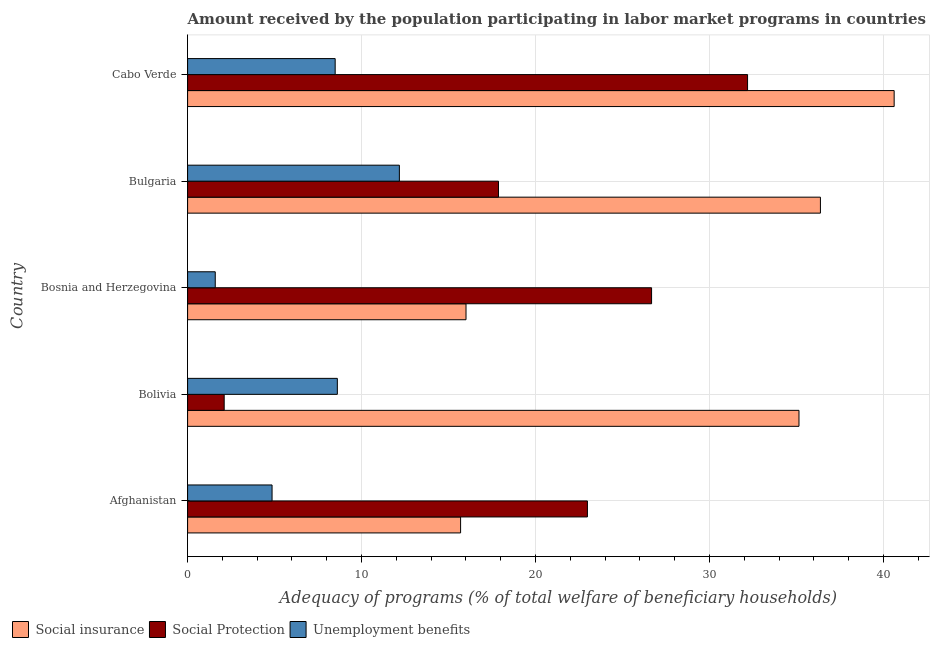Are the number of bars on each tick of the Y-axis equal?
Make the answer very short. Yes. How many bars are there on the 5th tick from the top?
Your answer should be very brief. 3. In how many cases, is the number of bars for a given country not equal to the number of legend labels?
Your answer should be very brief. 0. What is the amount received by the population participating in social protection programs in Bolivia?
Your answer should be compact. 2.1. Across all countries, what is the maximum amount received by the population participating in social protection programs?
Provide a short and direct response. 32.19. Across all countries, what is the minimum amount received by the population participating in social protection programs?
Offer a very short reply. 2.1. In which country was the amount received by the population participating in unemployment benefits programs maximum?
Give a very brief answer. Bulgaria. In which country was the amount received by the population participating in social insurance programs minimum?
Provide a short and direct response. Afghanistan. What is the total amount received by the population participating in social protection programs in the graph?
Your answer should be very brief. 101.83. What is the difference between the amount received by the population participating in social protection programs in Afghanistan and that in Bosnia and Herzegovina?
Offer a terse response. -3.69. What is the difference between the amount received by the population participating in social protection programs in Bulgaria and the amount received by the population participating in social insurance programs in Afghanistan?
Provide a short and direct response. 2.18. What is the average amount received by the population participating in unemployment benefits programs per country?
Your answer should be compact. 7.14. What is the difference between the amount received by the population participating in social insurance programs and amount received by the population participating in social protection programs in Bosnia and Herzegovina?
Your answer should be very brief. -10.67. In how many countries, is the amount received by the population participating in social protection programs greater than 6 %?
Provide a succinct answer. 4. What is the ratio of the amount received by the population participating in unemployment benefits programs in Bulgaria to that in Cabo Verde?
Your response must be concise. 1.44. Is the amount received by the population participating in social insurance programs in Bulgaria less than that in Cabo Verde?
Provide a succinct answer. Yes. Is the difference between the amount received by the population participating in unemployment benefits programs in Bosnia and Herzegovina and Cabo Verde greater than the difference between the amount received by the population participating in social insurance programs in Bosnia and Herzegovina and Cabo Verde?
Your answer should be very brief. Yes. What is the difference between the highest and the second highest amount received by the population participating in social insurance programs?
Provide a short and direct response. 4.24. What is the difference between the highest and the lowest amount received by the population participating in social insurance programs?
Your answer should be compact. 24.93. In how many countries, is the amount received by the population participating in unemployment benefits programs greater than the average amount received by the population participating in unemployment benefits programs taken over all countries?
Your answer should be very brief. 3. Is the sum of the amount received by the population participating in social insurance programs in Bosnia and Herzegovina and Cabo Verde greater than the maximum amount received by the population participating in unemployment benefits programs across all countries?
Provide a succinct answer. Yes. What does the 3rd bar from the top in Bosnia and Herzegovina represents?
Make the answer very short. Social insurance. What does the 3rd bar from the bottom in Bulgaria represents?
Offer a very short reply. Unemployment benefits. What is the difference between two consecutive major ticks on the X-axis?
Give a very brief answer. 10. Does the graph contain grids?
Your answer should be compact. Yes. How many legend labels are there?
Ensure brevity in your answer.  3. What is the title of the graph?
Ensure brevity in your answer.  Amount received by the population participating in labor market programs in countries. Does "Agriculture" appear as one of the legend labels in the graph?
Give a very brief answer. No. What is the label or title of the X-axis?
Your answer should be compact. Adequacy of programs (% of total welfare of beneficiary households). What is the Adequacy of programs (% of total welfare of beneficiary households) in Social insurance in Afghanistan?
Ensure brevity in your answer.  15.7. What is the Adequacy of programs (% of total welfare of beneficiary households) of Social Protection in Afghanistan?
Keep it short and to the point. 22.99. What is the Adequacy of programs (% of total welfare of beneficiary households) in Unemployment benefits in Afghanistan?
Your answer should be compact. 4.86. What is the Adequacy of programs (% of total welfare of beneficiary households) of Social insurance in Bolivia?
Give a very brief answer. 35.15. What is the Adequacy of programs (% of total welfare of beneficiary households) in Social Protection in Bolivia?
Offer a very short reply. 2.1. What is the Adequacy of programs (% of total welfare of beneficiary households) of Unemployment benefits in Bolivia?
Your answer should be very brief. 8.61. What is the Adequacy of programs (% of total welfare of beneficiary households) of Social insurance in Bosnia and Herzegovina?
Keep it short and to the point. 16.01. What is the Adequacy of programs (% of total welfare of beneficiary households) in Social Protection in Bosnia and Herzegovina?
Ensure brevity in your answer.  26.67. What is the Adequacy of programs (% of total welfare of beneficiary households) in Unemployment benefits in Bosnia and Herzegovina?
Provide a succinct answer. 1.59. What is the Adequacy of programs (% of total welfare of beneficiary households) in Social insurance in Bulgaria?
Your response must be concise. 36.38. What is the Adequacy of programs (% of total welfare of beneficiary households) in Social Protection in Bulgaria?
Your answer should be very brief. 17.87. What is the Adequacy of programs (% of total welfare of beneficiary households) of Unemployment benefits in Bulgaria?
Provide a succinct answer. 12.17. What is the Adequacy of programs (% of total welfare of beneficiary households) in Social insurance in Cabo Verde?
Your response must be concise. 40.62. What is the Adequacy of programs (% of total welfare of beneficiary households) in Social Protection in Cabo Verde?
Offer a terse response. 32.19. What is the Adequacy of programs (% of total welfare of beneficiary households) of Unemployment benefits in Cabo Verde?
Your response must be concise. 8.48. Across all countries, what is the maximum Adequacy of programs (% of total welfare of beneficiary households) in Social insurance?
Provide a short and direct response. 40.62. Across all countries, what is the maximum Adequacy of programs (% of total welfare of beneficiary households) of Social Protection?
Give a very brief answer. 32.19. Across all countries, what is the maximum Adequacy of programs (% of total welfare of beneficiary households) in Unemployment benefits?
Offer a terse response. 12.17. Across all countries, what is the minimum Adequacy of programs (% of total welfare of beneficiary households) in Social insurance?
Offer a very short reply. 15.7. Across all countries, what is the minimum Adequacy of programs (% of total welfare of beneficiary households) in Social Protection?
Ensure brevity in your answer.  2.1. Across all countries, what is the minimum Adequacy of programs (% of total welfare of beneficiary households) of Unemployment benefits?
Your answer should be very brief. 1.59. What is the total Adequacy of programs (% of total welfare of beneficiary households) in Social insurance in the graph?
Your answer should be very brief. 143.85. What is the total Adequacy of programs (% of total welfare of beneficiary households) in Social Protection in the graph?
Offer a terse response. 101.83. What is the total Adequacy of programs (% of total welfare of beneficiary households) in Unemployment benefits in the graph?
Offer a very short reply. 35.71. What is the difference between the Adequacy of programs (% of total welfare of beneficiary households) of Social insurance in Afghanistan and that in Bolivia?
Give a very brief answer. -19.45. What is the difference between the Adequacy of programs (% of total welfare of beneficiary households) of Social Protection in Afghanistan and that in Bolivia?
Make the answer very short. 20.88. What is the difference between the Adequacy of programs (% of total welfare of beneficiary households) in Unemployment benefits in Afghanistan and that in Bolivia?
Offer a terse response. -3.75. What is the difference between the Adequacy of programs (% of total welfare of beneficiary households) of Social insurance in Afghanistan and that in Bosnia and Herzegovina?
Keep it short and to the point. -0.31. What is the difference between the Adequacy of programs (% of total welfare of beneficiary households) in Social Protection in Afghanistan and that in Bosnia and Herzegovina?
Ensure brevity in your answer.  -3.69. What is the difference between the Adequacy of programs (% of total welfare of beneficiary households) of Unemployment benefits in Afghanistan and that in Bosnia and Herzegovina?
Ensure brevity in your answer.  3.27. What is the difference between the Adequacy of programs (% of total welfare of beneficiary households) in Social insurance in Afghanistan and that in Bulgaria?
Provide a short and direct response. -20.69. What is the difference between the Adequacy of programs (% of total welfare of beneficiary households) in Social Protection in Afghanistan and that in Bulgaria?
Ensure brevity in your answer.  5.11. What is the difference between the Adequacy of programs (% of total welfare of beneficiary households) in Unemployment benefits in Afghanistan and that in Bulgaria?
Keep it short and to the point. -7.32. What is the difference between the Adequacy of programs (% of total welfare of beneficiary households) of Social insurance in Afghanistan and that in Cabo Verde?
Offer a terse response. -24.93. What is the difference between the Adequacy of programs (% of total welfare of beneficiary households) in Social Protection in Afghanistan and that in Cabo Verde?
Ensure brevity in your answer.  -9.21. What is the difference between the Adequacy of programs (% of total welfare of beneficiary households) in Unemployment benefits in Afghanistan and that in Cabo Verde?
Make the answer very short. -3.63. What is the difference between the Adequacy of programs (% of total welfare of beneficiary households) of Social insurance in Bolivia and that in Bosnia and Herzegovina?
Your answer should be compact. 19.14. What is the difference between the Adequacy of programs (% of total welfare of beneficiary households) in Social Protection in Bolivia and that in Bosnia and Herzegovina?
Keep it short and to the point. -24.57. What is the difference between the Adequacy of programs (% of total welfare of beneficiary households) in Unemployment benefits in Bolivia and that in Bosnia and Herzegovina?
Give a very brief answer. 7.02. What is the difference between the Adequacy of programs (% of total welfare of beneficiary households) of Social insurance in Bolivia and that in Bulgaria?
Ensure brevity in your answer.  -1.23. What is the difference between the Adequacy of programs (% of total welfare of beneficiary households) of Social Protection in Bolivia and that in Bulgaria?
Make the answer very short. -15.77. What is the difference between the Adequacy of programs (% of total welfare of beneficiary households) of Unemployment benefits in Bolivia and that in Bulgaria?
Your response must be concise. -3.57. What is the difference between the Adequacy of programs (% of total welfare of beneficiary households) of Social insurance in Bolivia and that in Cabo Verde?
Make the answer very short. -5.47. What is the difference between the Adequacy of programs (% of total welfare of beneficiary households) of Social Protection in Bolivia and that in Cabo Verde?
Provide a short and direct response. -30.09. What is the difference between the Adequacy of programs (% of total welfare of beneficiary households) of Unemployment benefits in Bolivia and that in Cabo Verde?
Your answer should be very brief. 0.12. What is the difference between the Adequacy of programs (% of total welfare of beneficiary households) of Social insurance in Bosnia and Herzegovina and that in Bulgaria?
Provide a succinct answer. -20.38. What is the difference between the Adequacy of programs (% of total welfare of beneficiary households) of Social Protection in Bosnia and Herzegovina and that in Bulgaria?
Ensure brevity in your answer.  8.8. What is the difference between the Adequacy of programs (% of total welfare of beneficiary households) of Unemployment benefits in Bosnia and Herzegovina and that in Bulgaria?
Offer a terse response. -10.59. What is the difference between the Adequacy of programs (% of total welfare of beneficiary households) in Social insurance in Bosnia and Herzegovina and that in Cabo Verde?
Give a very brief answer. -24.61. What is the difference between the Adequacy of programs (% of total welfare of beneficiary households) in Social Protection in Bosnia and Herzegovina and that in Cabo Verde?
Your answer should be compact. -5.52. What is the difference between the Adequacy of programs (% of total welfare of beneficiary households) in Unemployment benefits in Bosnia and Herzegovina and that in Cabo Verde?
Your answer should be compact. -6.89. What is the difference between the Adequacy of programs (% of total welfare of beneficiary households) in Social insurance in Bulgaria and that in Cabo Verde?
Ensure brevity in your answer.  -4.24. What is the difference between the Adequacy of programs (% of total welfare of beneficiary households) in Social Protection in Bulgaria and that in Cabo Verde?
Make the answer very short. -14.32. What is the difference between the Adequacy of programs (% of total welfare of beneficiary households) of Unemployment benefits in Bulgaria and that in Cabo Verde?
Offer a terse response. 3.69. What is the difference between the Adequacy of programs (% of total welfare of beneficiary households) of Social insurance in Afghanistan and the Adequacy of programs (% of total welfare of beneficiary households) of Social Protection in Bolivia?
Your answer should be very brief. 13.59. What is the difference between the Adequacy of programs (% of total welfare of beneficiary households) of Social insurance in Afghanistan and the Adequacy of programs (% of total welfare of beneficiary households) of Unemployment benefits in Bolivia?
Offer a terse response. 7.09. What is the difference between the Adequacy of programs (% of total welfare of beneficiary households) of Social Protection in Afghanistan and the Adequacy of programs (% of total welfare of beneficiary households) of Unemployment benefits in Bolivia?
Offer a terse response. 14.38. What is the difference between the Adequacy of programs (% of total welfare of beneficiary households) in Social insurance in Afghanistan and the Adequacy of programs (% of total welfare of beneficiary households) in Social Protection in Bosnia and Herzegovina?
Your answer should be very brief. -10.98. What is the difference between the Adequacy of programs (% of total welfare of beneficiary households) of Social insurance in Afghanistan and the Adequacy of programs (% of total welfare of beneficiary households) of Unemployment benefits in Bosnia and Herzegovina?
Ensure brevity in your answer.  14.11. What is the difference between the Adequacy of programs (% of total welfare of beneficiary households) of Social Protection in Afghanistan and the Adequacy of programs (% of total welfare of beneficiary households) of Unemployment benefits in Bosnia and Herzegovina?
Make the answer very short. 21.4. What is the difference between the Adequacy of programs (% of total welfare of beneficiary households) in Social insurance in Afghanistan and the Adequacy of programs (% of total welfare of beneficiary households) in Social Protection in Bulgaria?
Your answer should be very brief. -2.18. What is the difference between the Adequacy of programs (% of total welfare of beneficiary households) in Social insurance in Afghanistan and the Adequacy of programs (% of total welfare of beneficiary households) in Unemployment benefits in Bulgaria?
Make the answer very short. 3.52. What is the difference between the Adequacy of programs (% of total welfare of beneficiary households) of Social Protection in Afghanistan and the Adequacy of programs (% of total welfare of beneficiary households) of Unemployment benefits in Bulgaria?
Offer a terse response. 10.81. What is the difference between the Adequacy of programs (% of total welfare of beneficiary households) of Social insurance in Afghanistan and the Adequacy of programs (% of total welfare of beneficiary households) of Social Protection in Cabo Verde?
Offer a terse response. -16.5. What is the difference between the Adequacy of programs (% of total welfare of beneficiary households) of Social insurance in Afghanistan and the Adequacy of programs (% of total welfare of beneficiary households) of Unemployment benefits in Cabo Verde?
Your answer should be compact. 7.21. What is the difference between the Adequacy of programs (% of total welfare of beneficiary households) in Social Protection in Afghanistan and the Adequacy of programs (% of total welfare of beneficiary households) in Unemployment benefits in Cabo Verde?
Your answer should be very brief. 14.5. What is the difference between the Adequacy of programs (% of total welfare of beneficiary households) in Social insurance in Bolivia and the Adequacy of programs (% of total welfare of beneficiary households) in Social Protection in Bosnia and Herzegovina?
Ensure brevity in your answer.  8.47. What is the difference between the Adequacy of programs (% of total welfare of beneficiary households) of Social insurance in Bolivia and the Adequacy of programs (% of total welfare of beneficiary households) of Unemployment benefits in Bosnia and Herzegovina?
Provide a succinct answer. 33.56. What is the difference between the Adequacy of programs (% of total welfare of beneficiary households) of Social Protection in Bolivia and the Adequacy of programs (% of total welfare of beneficiary households) of Unemployment benefits in Bosnia and Herzegovina?
Ensure brevity in your answer.  0.51. What is the difference between the Adequacy of programs (% of total welfare of beneficiary households) of Social insurance in Bolivia and the Adequacy of programs (% of total welfare of beneficiary households) of Social Protection in Bulgaria?
Offer a very short reply. 17.28. What is the difference between the Adequacy of programs (% of total welfare of beneficiary households) of Social insurance in Bolivia and the Adequacy of programs (% of total welfare of beneficiary households) of Unemployment benefits in Bulgaria?
Your answer should be very brief. 22.97. What is the difference between the Adequacy of programs (% of total welfare of beneficiary households) of Social Protection in Bolivia and the Adequacy of programs (% of total welfare of beneficiary households) of Unemployment benefits in Bulgaria?
Offer a terse response. -10.07. What is the difference between the Adequacy of programs (% of total welfare of beneficiary households) of Social insurance in Bolivia and the Adequacy of programs (% of total welfare of beneficiary households) of Social Protection in Cabo Verde?
Your answer should be compact. 2.96. What is the difference between the Adequacy of programs (% of total welfare of beneficiary households) of Social insurance in Bolivia and the Adequacy of programs (% of total welfare of beneficiary households) of Unemployment benefits in Cabo Verde?
Your response must be concise. 26.66. What is the difference between the Adequacy of programs (% of total welfare of beneficiary households) of Social Protection in Bolivia and the Adequacy of programs (% of total welfare of beneficiary households) of Unemployment benefits in Cabo Verde?
Offer a very short reply. -6.38. What is the difference between the Adequacy of programs (% of total welfare of beneficiary households) of Social insurance in Bosnia and Herzegovina and the Adequacy of programs (% of total welfare of beneficiary households) of Social Protection in Bulgaria?
Your response must be concise. -1.87. What is the difference between the Adequacy of programs (% of total welfare of beneficiary households) of Social insurance in Bosnia and Herzegovina and the Adequacy of programs (% of total welfare of beneficiary households) of Unemployment benefits in Bulgaria?
Your response must be concise. 3.83. What is the difference between the Adequacy of programs (% of total welfare of beneficiary households) of Social Protection in Bosnia and Herzegovina and the Adequacy of programs (% of total welfare of beneficiary households) of Unemployment benefits in Bulgaria?
Make the answer very short. 14.5. What is the difference between the Adequacy of programs (% of total welfare of beneficiary households) of Social insurance in Bosnia and Herzegovina and the Adequacy of programs (% of total welfare of beneficiary households) of Social Protection in Cabo Verde?
Give a very brief answer. -16.19. What is the difference between the Adequacy of programs (% of total welfare of beneficiary households) of Social insurance in Bosnia and Herzegovina and the Adequacy of programs (% of total welfare of beneficiary households) of Unemployment benefits in Cabo Verde?
Offer a terse response. 7.52. What is the difference between the Adequacy of programs (% of total welfare of beneficiary households) in Social Protection in Bosnia and Herzegovina and the Adequacy of programs (% of total welfare of beneficiary households) in Unemployment benefits in Cabo Verde?
Provide a succinct answer. 18.19. What is the difference between the Adequacy of programs (% of total welfare of beneficiary households) of Social insurance in Bulgaria and the Adequacy of programs (% of total welfare of beneficiary households) of Social Protection in Cabo Verde?
Offer a terse response. 4.19. What is the difference between the Adequacy of programs (% of total welfare of beneficiary households) in Social insurance in Bulgaria and the Adequacy of programs (% of total welfare of beneficiary households) in Unemployment benefits in Cabo Verde?
Offer a very short reply. 27.9. What is the difference between the Adequacy of programs (% of total welfare of beneficiary households) in Social Protection in Bulgaria and the Adequacy of programs (% of total welfare of beneficiary households) in Unemployment benefits in Cabo Verde?
Provide a succinct answer. 9.39. What is the average Adequacy of programs (% of total welfare of beneficiary households) in Social insurance per country?
Make the answer very short. 28.77. What is the average Adequacy of programs (% of total welfare of beneficiary households) in Social Protection per country?
Offer a terse response. 20.37. What is the average Adequacy of programs (% of total welfare of beneficiary households) of Unemployment benefits per country?
Ensure brevity in your answer.  7.14. What is the difference between the Adequacy of programs (% of total welfare of beneficiary households) of Social insurance and Adequacy of programs (% of total welfare of beneficiary households) of Social Protection in Afghanistan?
Your answer should be compact. -7.29. What is the difference between the Adequacy of programs (% of total welfare of beneficiary households) in Social insurance and Adequacy of programs (% of total welfare of beneficiary households) in Unemployment benefits in Afghanistan?
Offer a very short reply. 10.84. What is the difference between the Adequacy of programs (% of total welfare of beneficiary households) in Social Protection and Adequacy of programs (% of total welfare of beneficiary households) in Unemployment benefits in Afghanistan?
Ensure brevity in your answer.  18.13. What is the difference between the Adequacy of programs (% of total welfare of beneficiary households) in Social insurance and Adequacy of programs (% of total welfare of beneficiary households) in Social Protection in Bolivia?
Provide a short and direct response. 33.05. What is the difference between the Adequacy of programs (% of total welfare of beneficiary households) in Social insurance and Adequacy of programs (% of total welfare of beneficiary households) in Unemployment benefits in Bolivia?
Provide a short and direct response. 26.54. What is the difference between the Adequacy of programs (% of total welfare of beneficiary households) of Social Protection and Adequacy of programs (% of total welfare of beneficiary households) of Unemployment benefits in Bolivia?
Your answer should be compact. -6.51. What is the difference between the Adequacy of programs (% of total welfare of beneficiary households) of Social insurance and Adequacy of programs (% of total welfare of beneficiary households) of Social Protection in Bosnia and Herzegovina?
Your answer should be very brief. -10.67. What is the difference between the Adequacy of programs (% of total welfare of beneficiary households) in Social insurance and Adequacy of programs (% of total welfare of beneficiary households) in Unemployment benefits in Bosnia and Herzegovina?
Offer a very short reply. 14.42. What is the difference between the Adequacy of programs (% of total welfare of beneficiary households) of Social Protection and Adequacy of programs (% of total welfare of beneficiary households) of Unemployment benefits in Bosnia and Herzegovina?
Provide a succinct answer. 25.09. What is the difference between the Adequacy of programs (% of total welfare of beneficiary households) in Social insurance and Adequacy of programs (% of total welfare of beneficiary households) in Social Protection in Bulgaria?
Offer a very short reply. 18.51. What is the difference between the Adequacy of programs (% of total welfare of beneficiary households) of Social insurance and Adequacy of programs (% of total welfare of beneficiary households) of Unemployment benefits in Bulgaria?
Provide a succinct answer. 24.21. What is the difference between the Adequacy of programs (% of total welfare of beneficiary households) of Social Protection and Adequacy of programs (% of total welfare of beneficiary households) of Unemployment benefits in Bulgaria?
Keep it short and to the point. 5.7. What is the difference between the Adequacy of programs (% of total welfare of beneficiary households) of Social insurance and Adequacy of programs (% of total welfare of beneficiary households) of Social Protection in Cabo Verde?
Offer a very short reply. 8.43. What is the difference between the Adequacy of programs (% of total welfare of beneficiary households) in Social insurance and Adequacy of programs (% of total welfare of beneficiary households) in Unemployment benefits in Cabo Verde?
Make the answer very short. 32.14. What is the difference between the Adequacy of programs (% of total welfare of beneficiary households) in Social Protection and Adequacy of programs (% of total welfare of beneficiary households) in Unemployment benefits in Cabo Verde?
Your answer should be compact. 23.71. What is the ratio of the Adequacy of programs (% of total welfare of beneficiary households) in Social insurance in Afghanistan to that in Bolivia?
Offer a very short reply. 0.45. What is the ratio of the Adequacy of programs (% of total welfare of beneficiary households) of Social Protection in Afghanistan to that in Bolivia?
Your answer should be very brief. 10.93. What is the ratio of the Adequacy of programs (% of total welfare of beneficiary households) of Unemployment benefits in Afghanistan to that in Bolivia?
Provide a short and direct response. 0.56. What is the ratio of the Adequacy of programs (% of total welfare of beneficiary households) in Social insurance in Afghanistan to that in Bosnia and Herzegovina?
Your response must be concise. 0.98. What is the ratio of the Adequacy of programs (% of total welfare of beneficiary households) in Social Protection in Afghanistan to that in Bosnia and Herzegovina?
Make the answer very short. 0.86. What is the ratio of the Adequacy of programs (% of total welfare of beneficiary households) of Unemployment benefits in Afghanistan to that in Bosnia and Herzegovina?
Provide a short and direct response. 3.06. What is the ratio of the Adequacy of programs (% of total welfare of beneficiary households) in Social insurance in Afghanistan to that in Bulgaria?
Your answer should be very brief. 0.43. What is the ratio of the Adequacy of programs (% of total welfare of beneficiary households) in Social Protection in Afghanistan to that in Bulgaria?
Provide a succinct answer. 1.29. What is the ratio of the Adequacy of programs (% of total welfare of beneficiary households) of Unemployment benefits in Afghanistan to that in Bulgaria?
Ensure brevity in your answer.  0.4. What is the ratio of the Adequacy of programs (% of total welfare of beneficiary households) in Social insurance in Afghanistan to that in Cabo Verde?
Give a very brief answer. 0.39. What is the ratio of the Adequacy of programs (% of total welfare of beneficiary households) of Social Protection in Afghanistan to that in Cabo Verde?
Offer a terse response. 0.71. What is the ratio of the Adequacy of programs (% of total welfare of beneficiary households) in Unemployment benefits in Afghanistan to that in Cabo Verde?
Keep it short and to the point. 0.57. What is the ratio of the Adequacy of programs (% of total welfare of beneficiary households) of Social insurance in Bolivia to that in Bosnia and Herzegovina?
Offer a terse response. 2.2. What is the ratio of the Adequacy of programs (% of total welfare of beneficiary households) of Social Protection in Bolivia to that in Bosnia and Herzegovina?
Offer a very short reply. 0.08. What is the ratio of the Adequacy of programs (% of total welfare of beneficiary households) of Unemployment benefits in Bolivia to that in Bosnia and Herzegovina?
Offer a very short reply. 5.42. What is the ratio of the Adequacy of programs (% of total welfare of beneficiary households) in Social insurance in Bolivia to that in Bulgaria?
Give a very brief answer. 0.97. What is the ratio of the Adequacy of programs (% of total welfare of beneficiary households) of Social Protection in Bolivia to that in Bulgaria?
Give a very brief answer. 0.12. What is the ratio of the Adequacy of programs (% of total welfare of beneficiary households) in Unemployment benefits in Bolivia to that in Bulgaria?
Give a very brief answer. 0.71. What is the ratio of the Adequacy of programs (% of total welfare of beneficiary households) in Social insurance in Bolivia to that in Cabo Verde?
Offer a terse response. 0.87. What is the ratio of the Adequacy of programs (% of total welfare of beneficiary households) of Social Protection in Bolivia to that in Cabo Verde?
Make the answer very short. 0.07. What is the ratio of the Adequacy of programs (% of total welfare of beneficiary households) in Unemployment benefits in Bolivia to that in Cabo Verde?
Make the answer very short. 1.01. What is the ratio of the Adequacy of programs (% of total welfare of beneficiary households) of Social insurance in Bosnia and Herzegovina to that in Bulgaria?
Keep it short and to the point. 0.44. What is the ratio of the Adequacy of programs (% of total welfare of beneficiary households) of Social Protection in Bosnia and Herzegovina to that in Bulgaria?
Give a very brief answer. 1.49. What is the ratio of the Adequacy of programs (% of total welfare of beneficiary households) of Unemployment benefits in Bosnia and Herzegovina to that in Bulgaria?
Your response must be concise. 0.13. What is the ratio of the Adequacy of programs (% of total welfare of beneficiary households) in Social insurance in Bosnia and Herzegovina to that in Cabo Verde?
Ensure brevity in your answer.  0.39. What is the ratio of the Adequacy of programs (% of total welfare of beneficiary households) in Social Protection in Bosnia and Herzegovina to that in Cabo Verde?
Your response must be concise. 0.83. What is the ratio of the Adequacy of programs (% of total welfare of beneficiary households) of Unemployment benefits in Bosnia and Herzegovina to that in Cabo Verde?
Give a very brief answer. 0.19. What is the ratio of the Adequacy of programs (% of total welfare of beneficiary households) of Social insurance in Bulgaria to that in Cabo Verde?
Your answer should be very brief. 0.9. What is the ratio of the Adequacy of programs (% of total welfare of beneficiary households) in Social Protection in Bulgaria to that in Cabo Verde?
Provide a short and direct response. 0.56. What is the ratio of the Adequacy of programs (% of total welfare of beneficiary households) of Unemployment benefits in Bulgaria to that in Cabo Verde?
Offer a terse response. 1.44. What is the difference between the highest and the second highest Adequacy of programs (% of total welfare of beneficiary households) of Social insurance?
Your answer should be compact. 4.24. What is the difference between the highest and the second highest Adequacy of programs (% of total welfare of beneficiary households) of Social Protection?
Your answer should be very brief. 5.52. What is the difference between the highest and the second highest Adequacy of programs (% of total welfare of beneficiary households) of Unemployment benefits?
Offer a very short reply. 3.57. What is the difference between the highest and the lowest Adequacy of programs (% of total welfare of beneficiary households) of Social insurance?
Your answer should be compact. 24.93. What is the difference between the highest and the lowest Adequacy of programs (% of total welfare of beneficiary households) of Social Protection?
Ensure brevity in your answer.  30.09. What is the difference between the highest and the lowest Adequacy of programs (% of total welfare of beneficiary households) of Unemployment benefits?
Your response must be concise. 10.59. 